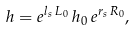<formula> <loc_0><loc_0><loc_500><loc_500>h = e ^ { l _ { s } \, L _ { 0 } } \, h _ { 0 } \, e ^ { r _ { s } \, R _ { 0 } } ,</formula> 